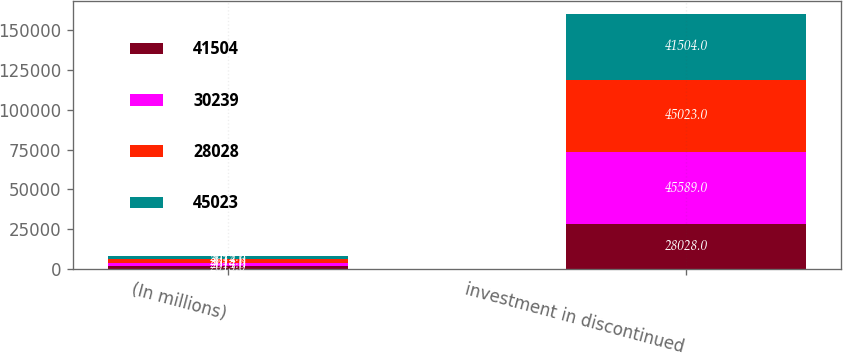Convert chart to OTSL. <chart><loc_0><loc_0><loc_500><loc_500><stacked_bar_chart><ecel><fcel>(In millions)<fcel>investment in discontinued<nl><fcel>41504<fcel>2015<fcel>28028<nl><fcel>30239<fcel>2014<fcel>45589<nl><fcel>28028<fcel>2013<fcel>45023<nl><fcel>45023<fcel>2012<fcel>41504<nl></chart> 